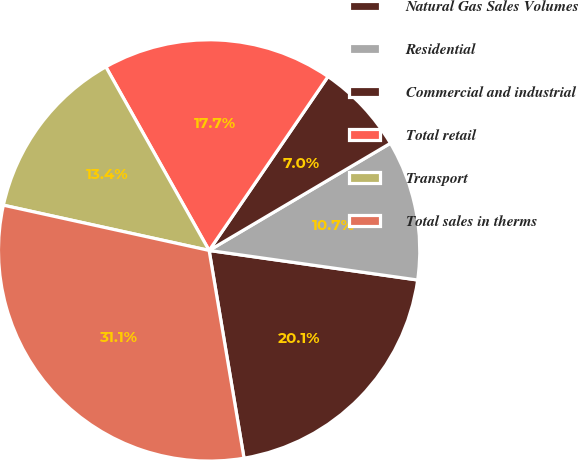Convert chart to OTSL. <chart><loc_0><loc_0><loc_500><loc_500><pie_chart><fcel>Natural Gas Sales Volumes<fcel>Residential<fcel>Commercial and industrial<fcel>Total retail<fcel>Transport<fcel>Total sales in therms<nl><fcel>20.11%<fcel>10.74%<fcel>6.96%<fcel>17.7%<fcel>13.4%<fcel>31.1%<nl></chart> 